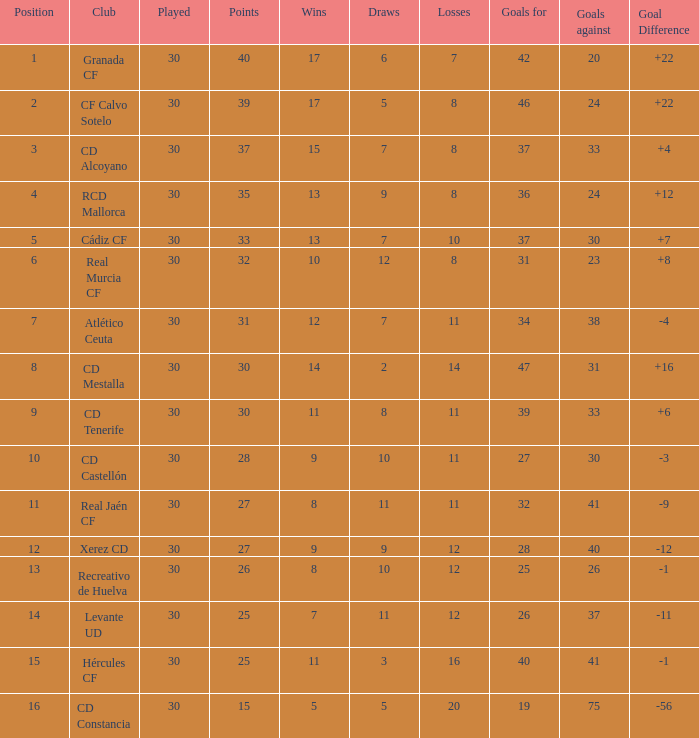How many draws have a total of 30 points and fewer than 33 goals against? 1.0. 